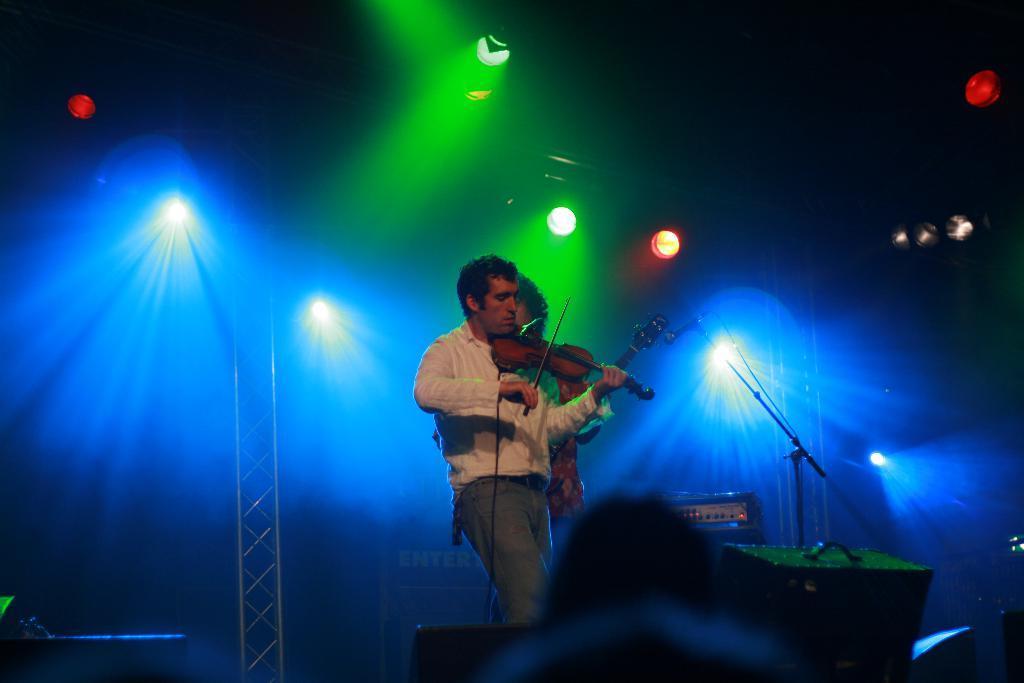In one or two sentences, can you explain what this image depicts? In the foreground I can see two persons are playing musical instruments on the stage. In the background I can see focus lights and metal rods. This image is taken on the stage. 